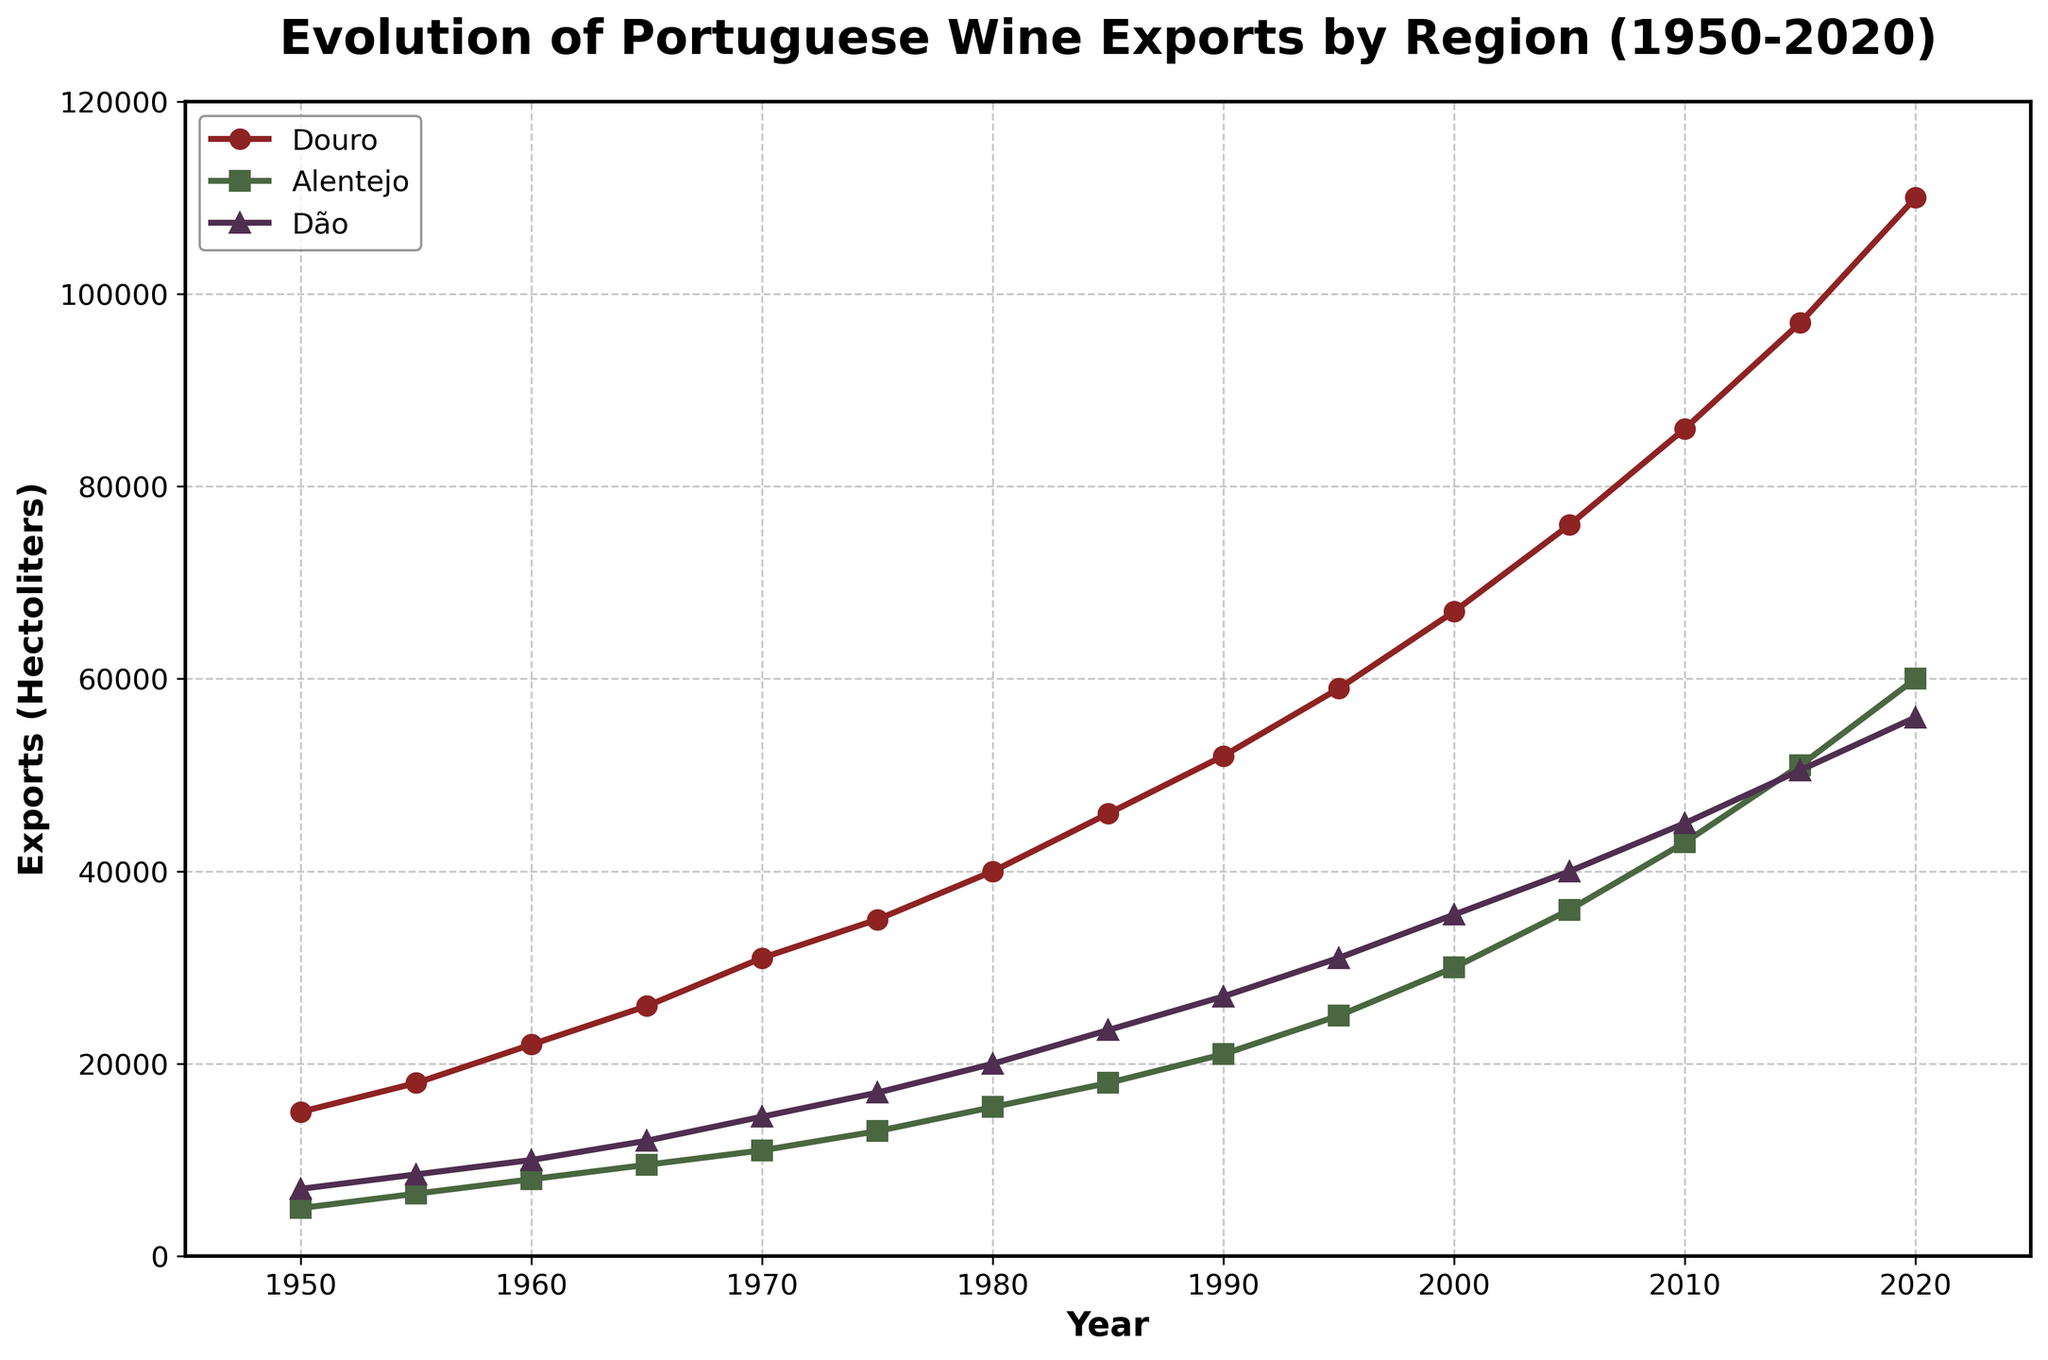What is the trend of wine exports for the Douro region from 1950 to 2020? The data shows a consistent increase in wine exports from the Douro region over the 70-year period, starting at 15,000 hectoliters in 1950 and reaching 110,000 hectoliters in 2020.
Answer: Increasing Which region had the highest wine exports in 2020? Comparing the end points of the lines for each region in 2020, the Douro region had the highest wine exports at 110,000 hectoliters.
Answer: Douro How many hectoliters of wine were exported by the Alentejo region in 1975? By looking at the Alentejo line, marked in green, the export value in 1975 is identified as 13,000 hectoliters.
Answer: 13,000 hectoliters Between which consecutive years did the Dão region see the highest growth in wine exports? Observing the steepness of the upward trends, the highest growth for Dão was between 1950 (7,000 hectoliters) and 1955 (8,500 hectoliters), a growth of 1,500 hectoliters.
Answer: 1950-1955 Which region had wine exports greater than 50,000 hectoliters first, and in which year? By analyzing the lines, Dão reached 50,500 hectoliters in 2015, whereas Douro reached 52,000 hectoliters by 1990, and Alentejo surpassed 50,000 hectoliters in 2015. Thus, Douro first achieved this in 1990.
Answer: Douro, 1990 What was the average wine export for the Alentejo region in the decade of 1980 to 1990? Summing the Alentejo values from 1980 (15,500 hectoliters) to 1990 (21,000 hectoliters) and dividing by the number of years (counting 1980, 1985, and 1990), we calculate: (15,500 + 18,000 + 21,000) / 3 = 18,833.33 hectoliters.
Answer: 18,833.33 hectoliters Did the Dão region ever surpass the Alentejo region in wine exports, and if so, when? By comparing the values along both lines, the Dão region surpassed Alentejo between 1950 and 1970 but was lower thereafter.
Answer: Yes, from 1950 to 1970 What is the combined total of wine exports for all three regions in the year 2000? Summing the export values for 2000, Douro: 67,000 hectoliters, Alentejo: 30,000 hectoliters, and Dão: 35,500 hectoliters. The combined total is 67,000 + 30,000 + 35,500 = 132,500 hectoliters.
Answer: 132,500 hectoliters In which year did the Douro region's wine exports first exceed 60,000 hectoliters? The Douro region exports surpassed 60,000 hectoliters in 1995, with a value of 59,000 hectoliters, and definitely achieved beyond this milestone by 2000 at 67,000 hectoliters.
Answer: 2000 